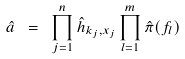Convert formula to latex. <formula><loc_0><loc_0><loc_500><loc_500>\hat { a } \ = \ \prod _ { j = 1 } ^ { n } \hat { h } _ { k _ { j } , x _ { j } } \prod _ { l = 1 } ^ { m } \hat { \pi } ( f _ { l } )</formula> 